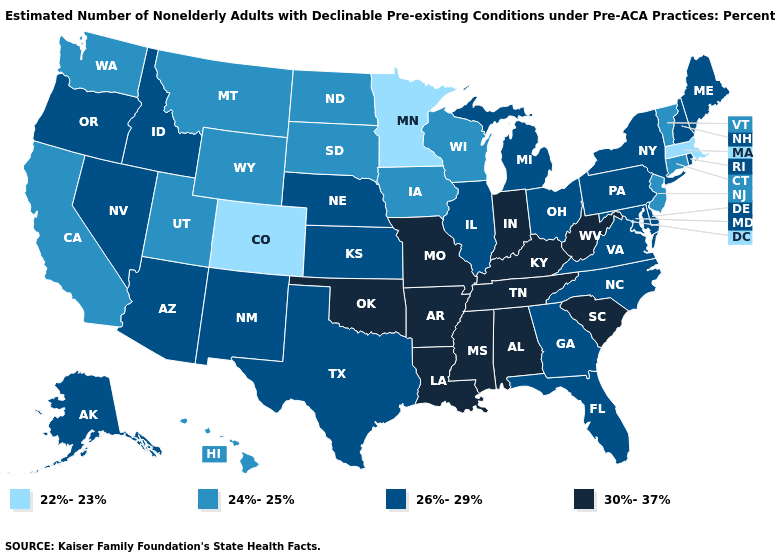Does Colorado have the lowest value in the West?
Write a very short answer. Yes. Name the states that have a value in the range 24%-25%?
Be succinct. California, Connecticut, Hawaii, Iowa, Montana, New Jersey, North Dakota, South Dakota, Utah, Vermont, Washington, Wisconsin, Wyoming. Does Nebraska have the highest value in the USA?
Answer briefly. No. What is the value of Minnesota?
Short answer required. 22%-23%. What is the value of Kansas?
Concise answer only. 26%-29%. Which states have the lowest value in the USA?
Keep it brief. Colorado, Massachusetts, Minnesota. Does Maine have the lowest value in the Northeast?
Answer briefly. No. Which states have the lowest value in the USA?
Keep it brief. Colorado, Massachusetts, Minnesota. Name the states that have a value in the range 26%-29%?
Answer briefly. Alaska, Arizona, Delaware, Florida, Georgia, Idaho, Illinois, Kansas, Maine, Maryland, Michigan, Nebraska, Nevada, New Hampshire, New Mexico, New York, North Carolina, Ohio, Oregon, Pennsylvania, Rhode Island, Texas, Virginia. What is the lowest value in the Northeast?
Short answer required. 22%-23%. Does the map have missing data?
Concise answer only. No. What is the value of Wyoming?
Write a very short answer. 24%-25%. Is the legend a continuous bar?
Answer briefly. No. Which states hav the highest value in the Northeast?
Be succinct. Maine, New Hampshire, New York, Pennsylvania, Rhode Island. Name the states that have a value in the range 30%-37%?
Concise answer only. Alabama, Arkansas, Indiana, Kentucky, Louisiana, Mississippi, Missouri, Oklahoma, South Carolina, Tennessee, West Virginia. 